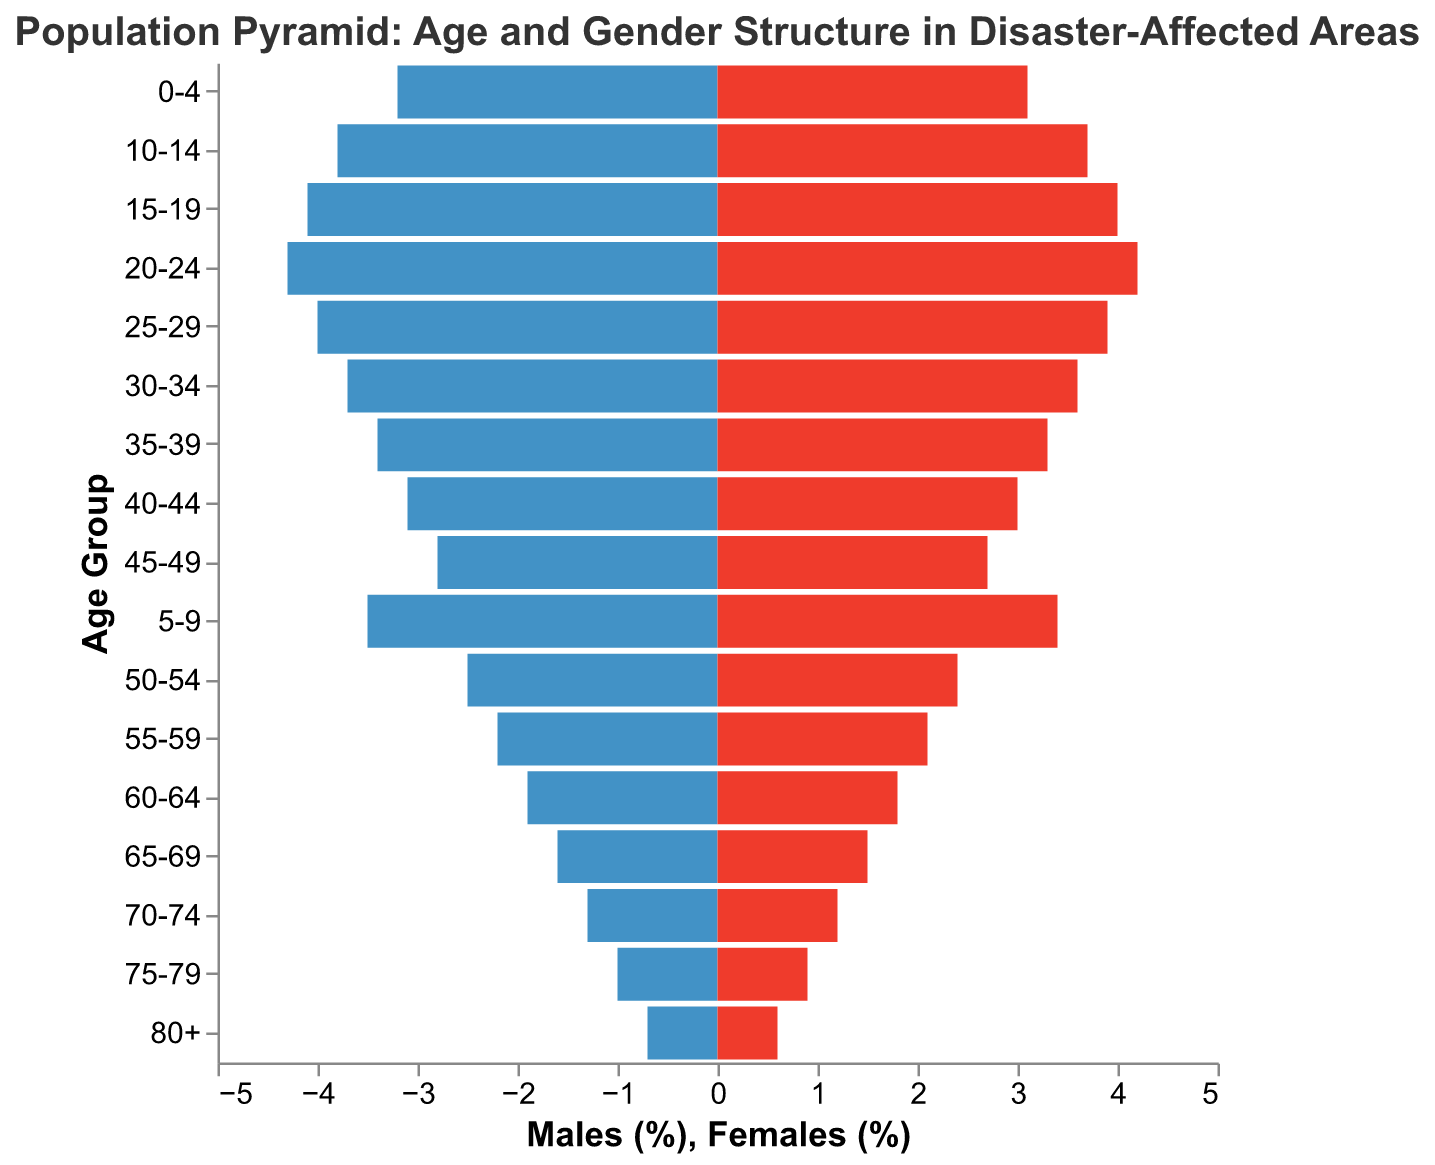What age group has the highest percentage of males? The age group with the highest percentage of males is identified by looking at the left bars that extend farthest to the left. The "20-24" age group has the longest bar in the negative direction.
Answer: 20-24 What age group has the highest percentage of females? The age group with the highest percentage of females is identified by looking at the right bars that extend farthest to the right. The "20-24" age group has the longest bar in the positive direction.
Answer: 20-24 Is there more population in the age group 0-4 or 70-74? To determine which age group has more population, compare the combined lengths of the male and female bars for each age group. For age group 0-4, both males and females add up to 6.3%. For age group 70-74, both males and females add up to 2.5%.
Answer: 0-4 Which age group shows the largest gender difference? The largest gender difference can be found by calculating the difference between the male and female percentages for each age group. The largest difference is observed in the "0-4" age group where males are 3.2% and females are 3.1%, indicating a 0.1% difference.
Answer: 0-4 How does the percentage of individuals aged 50-54 compare between males and females? Compare the percentages in the 50-54 age group on both sides of the pyramid. Males are at 2.5% and females are at 2.4%.
Answer: Males have a slightly higher percentage than females What’s the combined population percentage of individuals aged 40-49? To find the combined population percentage, add up both male and female percentages for the age groups "40-44" and "45-49." (3.1% + 3.0%) + (2.8% + 2.7%) = 11.6%
Answer: 11.6% How does the population percentage of those aged 15-19 compare to those aged 65-69? Compare the combined percentages for males and females in both age groups. For 15-19, it is 4.1% + 4.0% = 8.1%. For 65-69, it is 1.6% + 1.5% = 3.1%.
Answer: 15-19 has a higher percentage What can be inferred about the gender distribution within the 30-34 age group? For this age group, the percentage for males is 3.7% and for females is 3.6%. Since the values are almost equal, it indicates a nearly balanced gender distribution.
Answer: Nearly balanced How does the population percentage decline from age group 25-29 to 80+ for both genders? To understand the decline, compare the initial percentage of 25-29 (4.0% males, 3.9% females) with the final percentage of 80+ (0.7% males, 0.6% females). The decline in percentage can be observed visually as well as numerically.
Answer: Declines from 4.0%/3.9% to 0.7%/0.6% respectively 